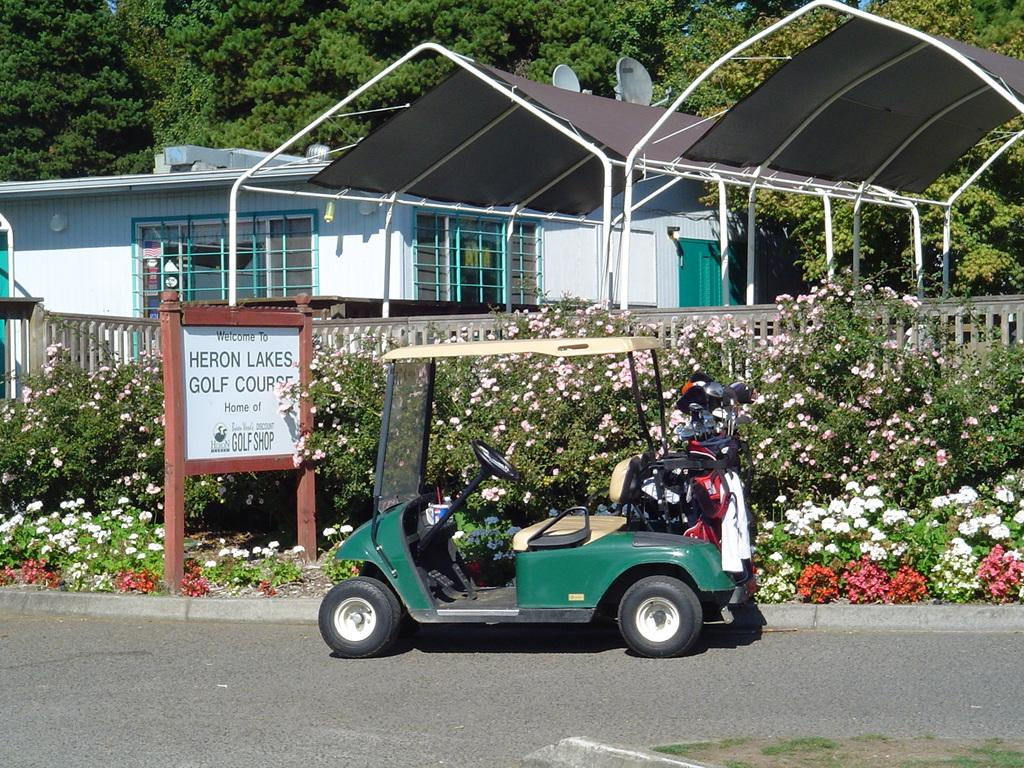What type of structures can be seen in the image? There are sheds and a house in the image. What architectural feature is present in the image? There are windows in the image. What type of vegetation is present in the image? There are trees in the image. What type of barrier is present in the image? There is fencing in the image. What type of signage is present in the image? There is a board in the image. What type of transportation is present in the image? There is a vehicle in the image. What type of flowers can be seen in the image? There are white and red color flowers in the image. How does the wind affect the waves in the image? There are no waves present in the image, as it features sheds, a house, trees, fencing, a board, a vehicle, and flowers. 